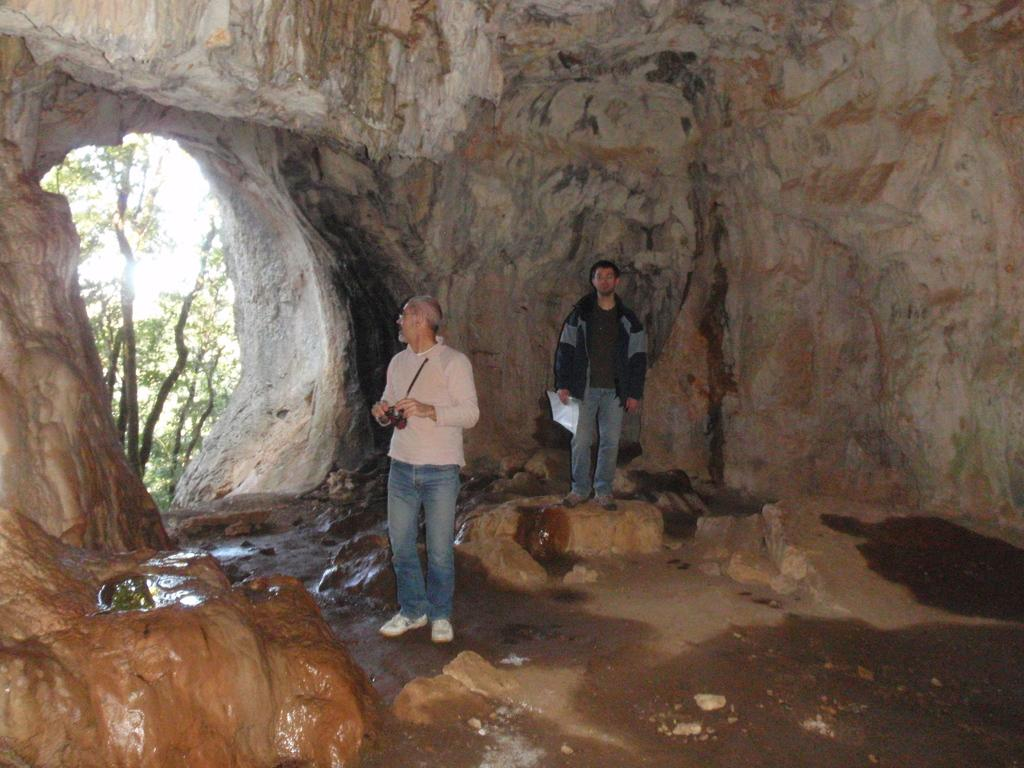How many people are in the image? There are two persons in the image. Where are the persons located? The persons are standing inside a cave. What can be seen in the background of the image? There are trees visible in the image. What type of jeans is the person on the left wearing in the image? There is no information about the type of jeans the person is wearing, as the provided facts do not mention clothing. 